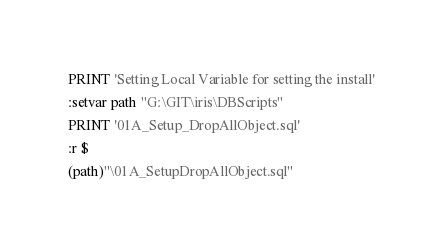Convert code to text. <code><loc_0><loc_0><loc_500><loc_500><_SQL_>PRINT 'Setting Local Variable for setting the install'
:setvar path "G:\GIT\iris\DBScripts"
PRINT '01A_Setup_DropAllObject.sql'
:r $
(path)"\01A_SetupDropAllObject.sql"
</code> 